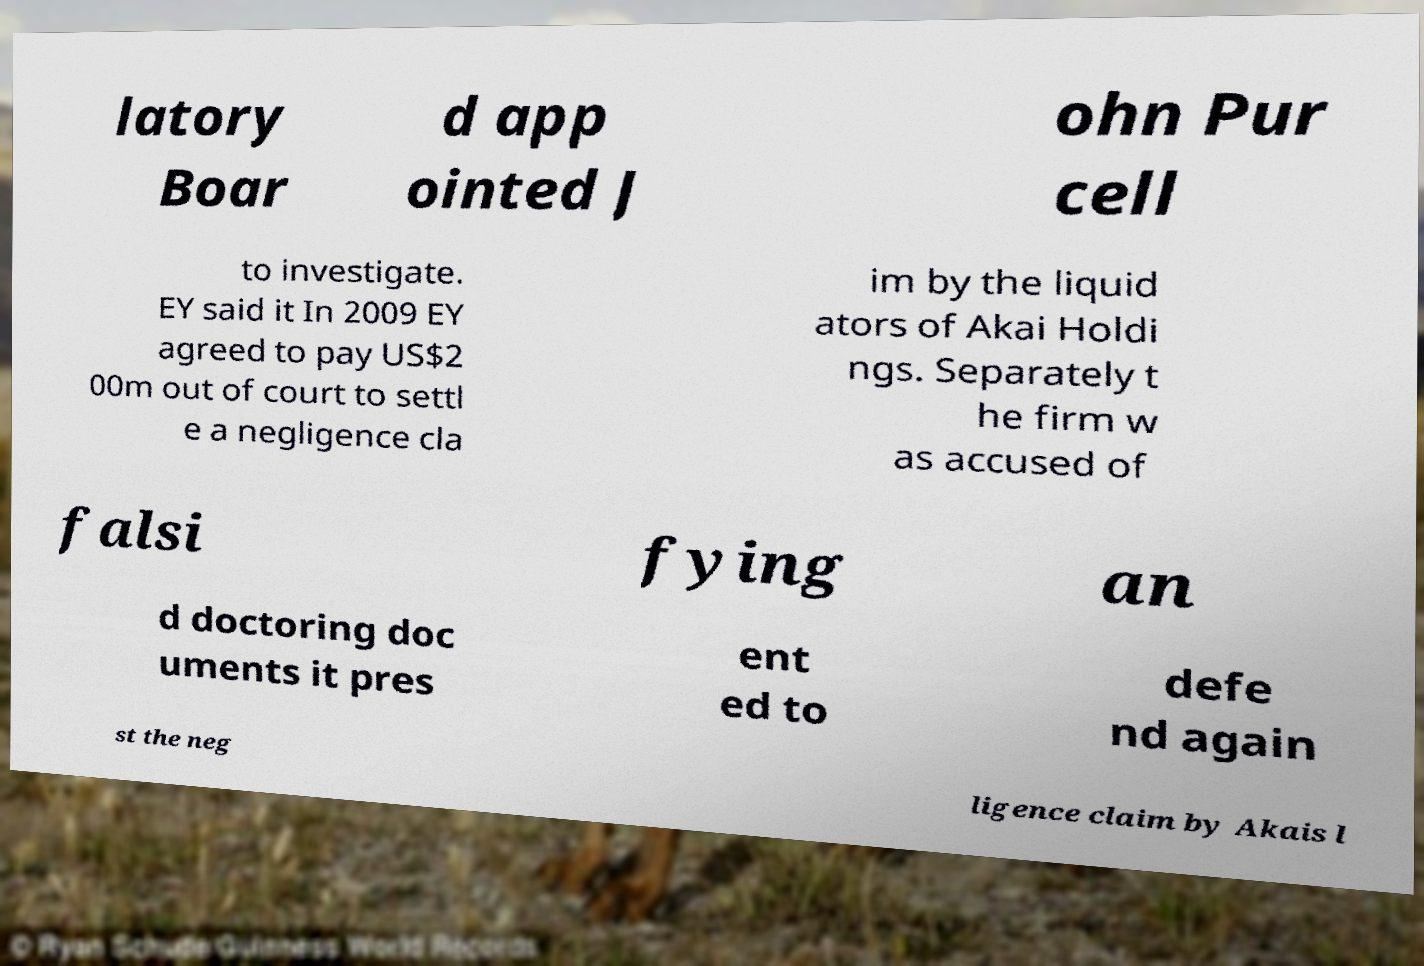There's text embedded in this image that I need extracted. Can you transcribe it verbatim? latory Boar d app ointed J ohn Pur cell to investigate. EY said it In 2009 EY agreed to pay US$2 00m out of court to settl e a negligence cla im by the liquid ators of Akai Holdi ngs. Separately t he firm w as accused of falsi fying an d doctoring doc uments it pres ent ed to defe nd again st the neg ligence claim by Akais l 